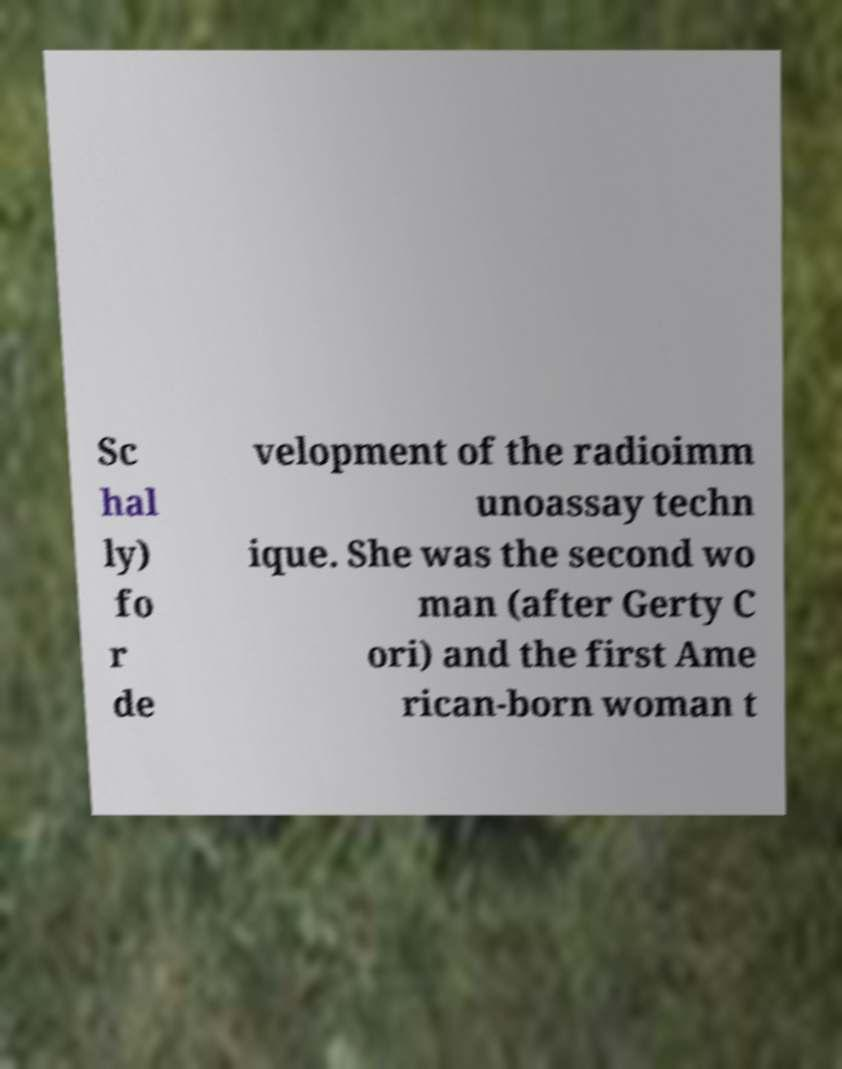There's text embedded in this image that I need extracted. Can you transcribe it verbatim? Sc hal ly) fo r de velopment of the radioimm unoassay techn ique. She was the second wo man (after Gerty C ori) and the first Ame rican-born woman t 